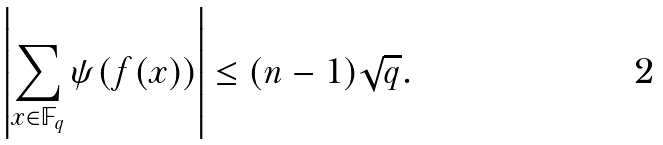Convert formula to latex. <formula><loc_0><loc_0><loc_500><loc_500>\left | \sum _ { x \in \mathbb { F } _ { q } } \psi ( f ( x ) ) \right | \leq ( n - 1 ) \sqrt { q } .</formula> 